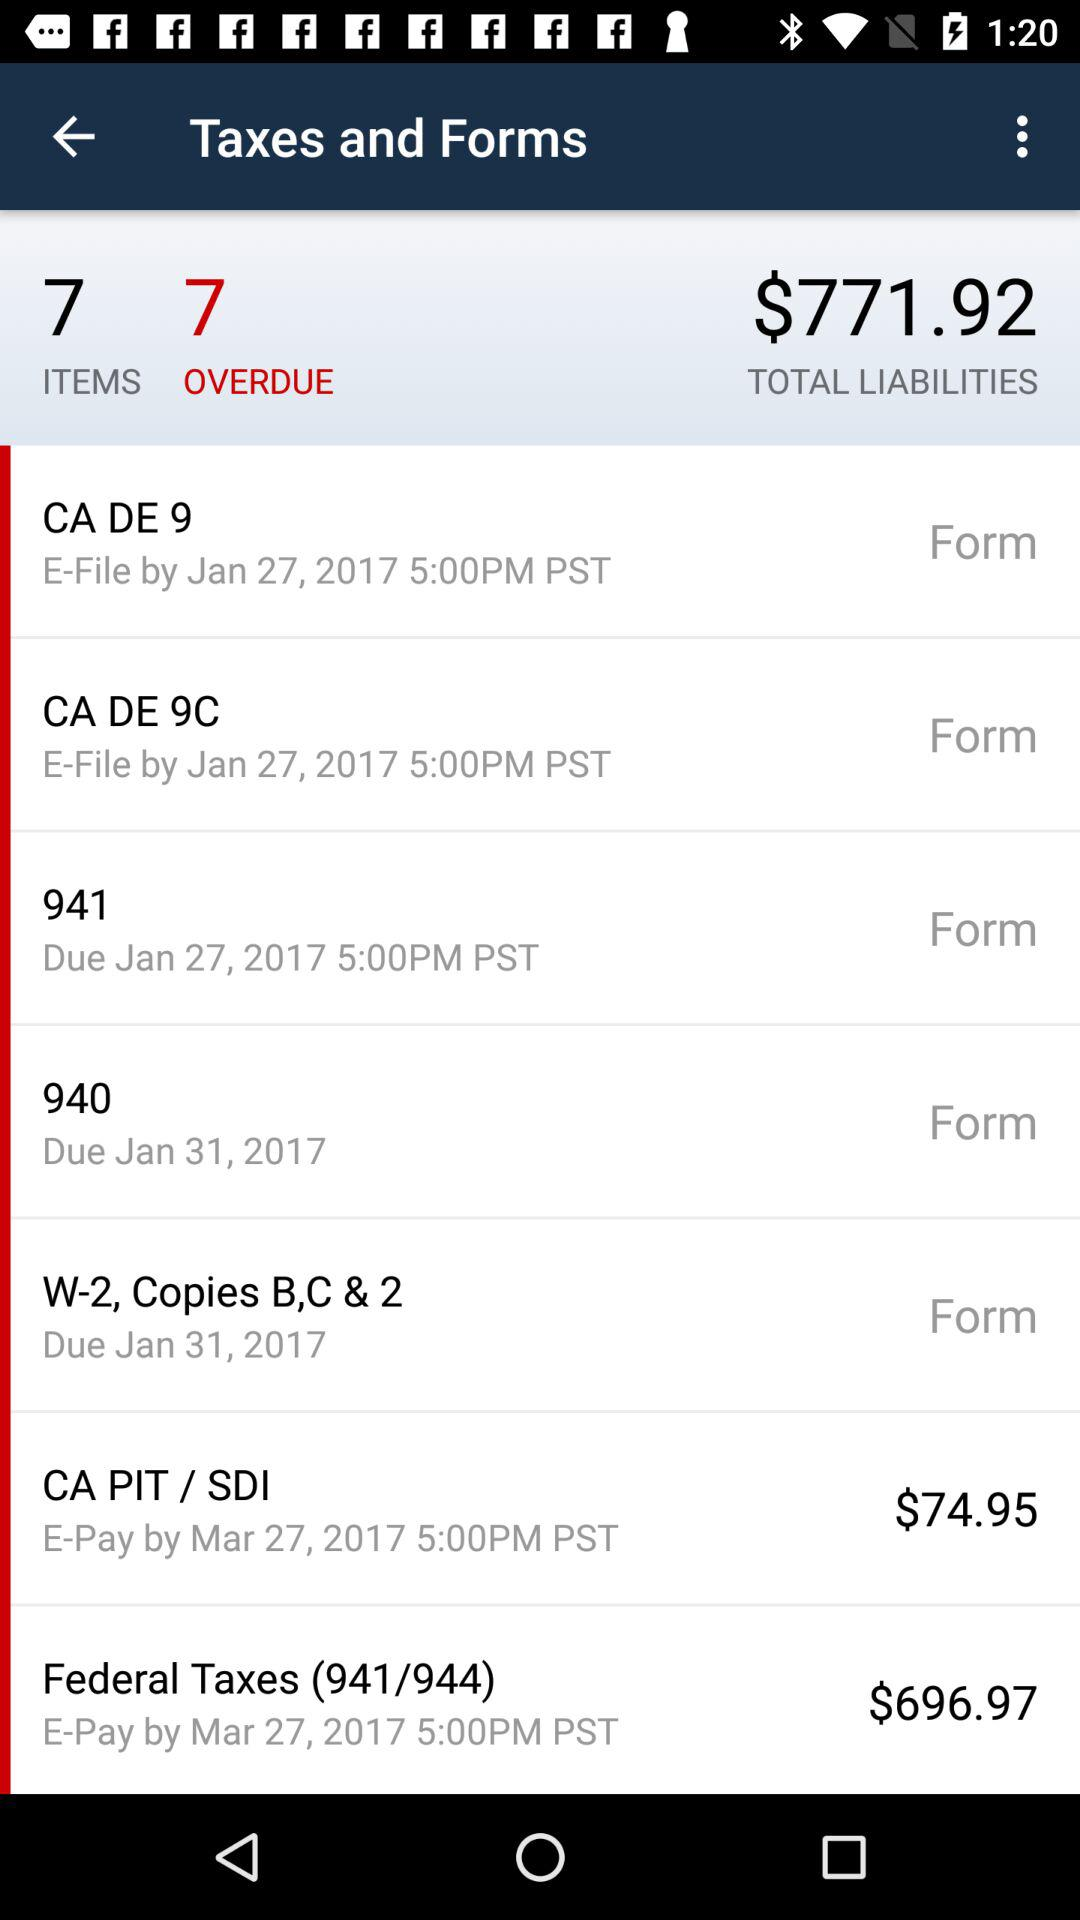What is the due date of 941? The due date is Jan 27, 2017. 